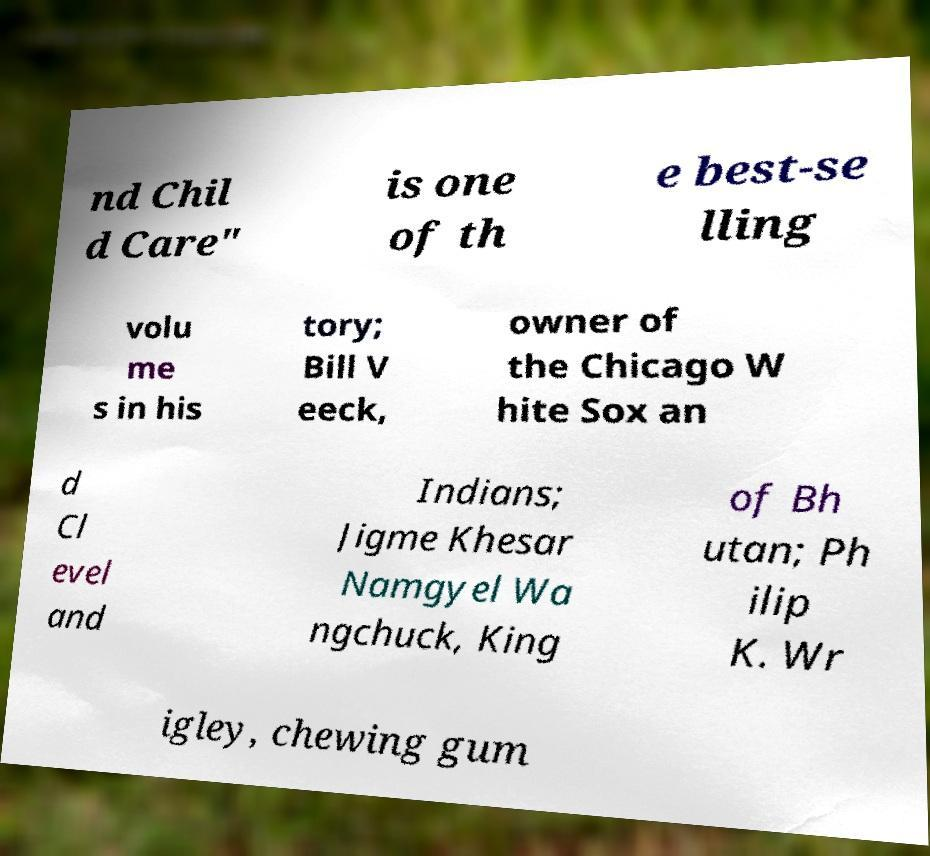There's text embedded in this image that I need extracted. Can you transcribe it verbatim? nd Chil d Care" is one of th e best-se lling volu me s in his tory; Bill V eeck, owner of the Chicago W hite Sox an d Cl evel and Indians; Jigme Khesar Namgyel Wa ngchuck, King of Bh utan; Ph ilip K. Wr igley, chewing gum 